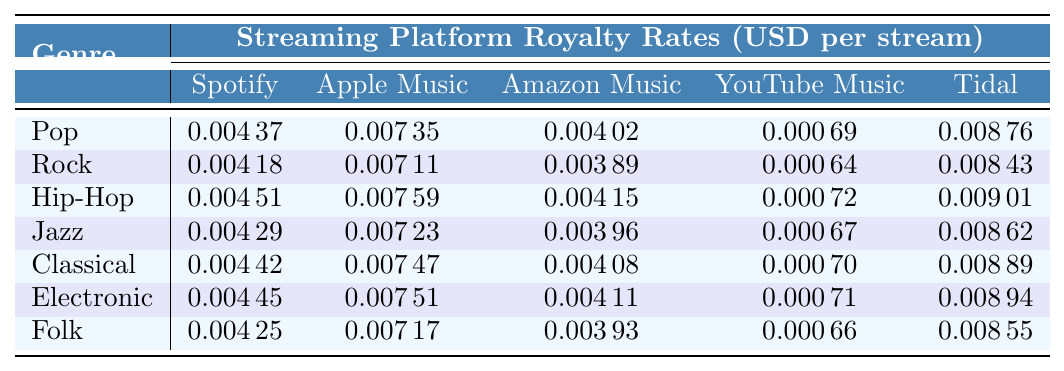What is the highest royalty rate for independent artists on Spotify? The table shows the royalty rates for independent artists by genre on Spotify. By comparing the listed values, Hip-Hop has the highest rate at 0.00451.
Answer: 0.00451 Which streaming platform pays the highest royalty rate for Classical music? The table shows the royalty rates for Classical music across all platforms. Tidal pays the highest rate of 0.00889.
Answer: 0.00889 What is the average royalty rate for Pop across all platforms? To calculate the average, add the Pop rates for each platform: 0.00437 + 0.00735 + 0.00402 + 0.00069 + 0.00876 = 0.02519, then divide by 5 to get the average: 0.02519 / 5 = 0.005038.
Answer: 0.00504 Is the YouTube Music royalty rate higher for Jazz than for Rock? The table lists YouTube Music rates: Jazz at 0.00067 and Rock at 0.00064. Since 0.00067 is greater than 0.00064, the statement is true.
Answer: Yes What is the difference in royalty rates between Electronic and Folk music on Apple Music? The table shows the Electronic rate at 0.00751 and Folk at 0.00717. To find the difference, subtract Folk from Electronic: 0.00751 - 0.00717 = 0.00034.
Answer: 0.00034 Which genre has the lowest royalty rate on Amazon Music? Checking the rates in the table, Folk has the lowest rate at 0.00393 compared to all other genres.
Answer: Folk If an artist streams a Pop song on Tidal 1,000 times, how much would they earn? The Tidal rate for Pop is 0.00876. Multiply 0.00876 by 1,000: 0.00876 * 1,000 = 8.76.
Answer: 8.76 Are the royalty rates for Rock and Jazz on Spotify equal? The table shows Rock at 0.00418 and Jazz at 0.00429 on Spotify. Since these values are different, they are not equal.
Answer: No What is the total royalty rate for Hip-Hop across all streaming platforms? By adding the Hip-Hop rates together: 0.00451 + 0.00759 + 0.00415 + 0.00072 + 0.00901 = 0.02598.
Answer: 0.02598 Which genre earns the most per stream on Tidal? The table shows the Tidal rates: Pop 0.00876, Rock 0.00843, Hip-Hop 0.00901, Jazz 0.00862, Classical 0.00889, Electronic 0.00894, and Folk 0.00855. Hip-Hop has the highest rate at 0.00901.
Answer: Hip-Hop 